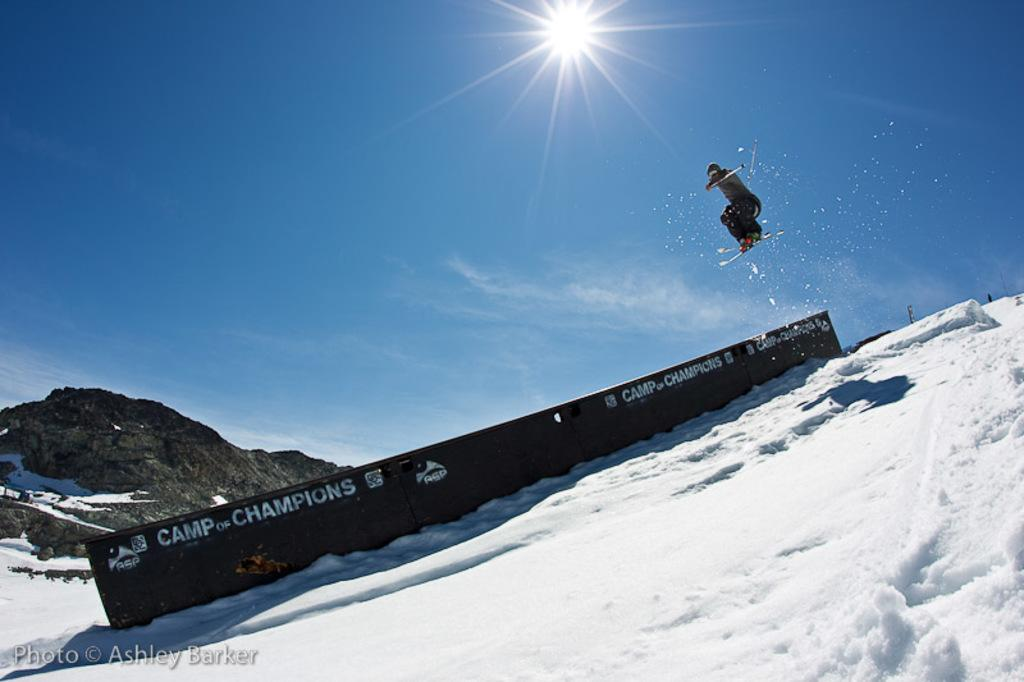<image>
Share a concise interpretation of the image provided. A snowboarder sails in the air in front of a sign saying Camp of Champions. 